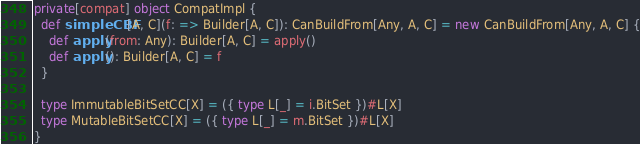<code> <loc_0><loc_0><loc_500><loc_500><_Scala_>private[compat] object CompatImpl {
  def simpleCBF[A, C](f: => Builder[A, C]): CanBuildFrom[Any, A, C] = new CanBuildFrom[Any, A, C] {
    def apply(from: Any): Builder[A, C] = apply()
    def apply(): Builder[A, C] = f
  }

  type ImmutableBitSetCC[X] = ({ type L[_] = i.BitSet })#L[X]
  type MutableBitSetCC[X] = ({ type L[_] = m.BitSet })#L[X]
}
</code> 